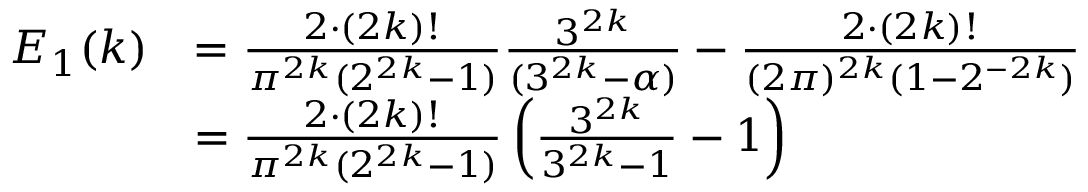<formula> <loc_0><loc_0><loc_500><loc_500>\begin{array} { r l } { E _ { 1 } ( k ) } & { = \frac { 2 \cdot ( 2 k ) ! } { \pi ^ { 2 k } ( 2 ^ { 2 k } - 1 ) } \frac { 3 ^ { 2 k } } { ( 3 ^ { 2 k } - \alpha ) } - \frac { 2 \cdot ( 2 k ) ! } { ( 2 \pi ) ^ { 2 k } ( 1 - 2 ^ { - 2 k } ) } } \\ & { = \frac { 2 \cdot ( 2 k ) ! } { \pi ^ { 2 k } ( 2 ^ { 2 k } - 1 ) } \left ( \frac { 3 ^ { 2 k } } { 3 ^ { 2 k } - 1 } - 1 \right ) } \end{array}</formula> 